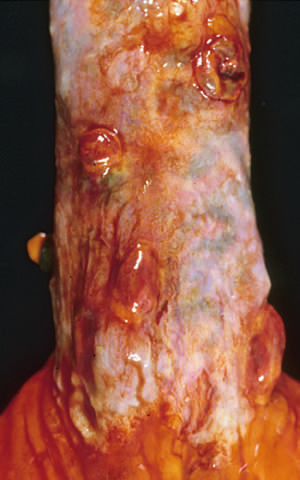re the polypoid areas sites of variceal hemorrhage that were ligated with bands?
Answer the question using a single word or phrase. Yes 